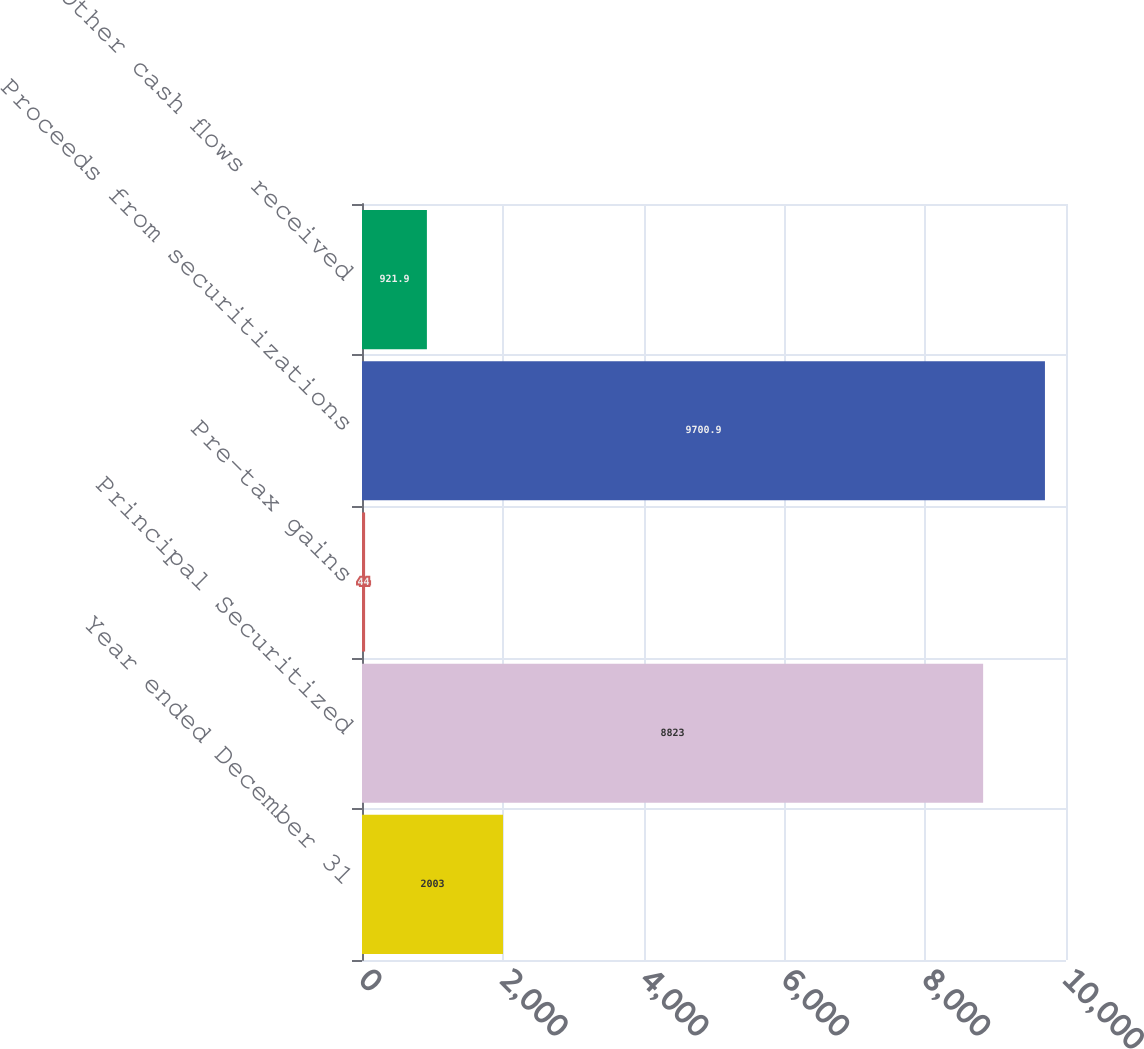Convert chart to OTSL. <chart><loc_0><loc_0><loc_500><loc_500><bar_chart><fcel>Year ended December 31<fcel>Principal Securitized<fcel>Pre-tax gains<fcel>Proceeds from securitizations<fcel>Other cash flows received<nl><fcel>2003<fcel>8823<fcel>44<fcel>9700.9<fcel>921.9<nl></chart> 